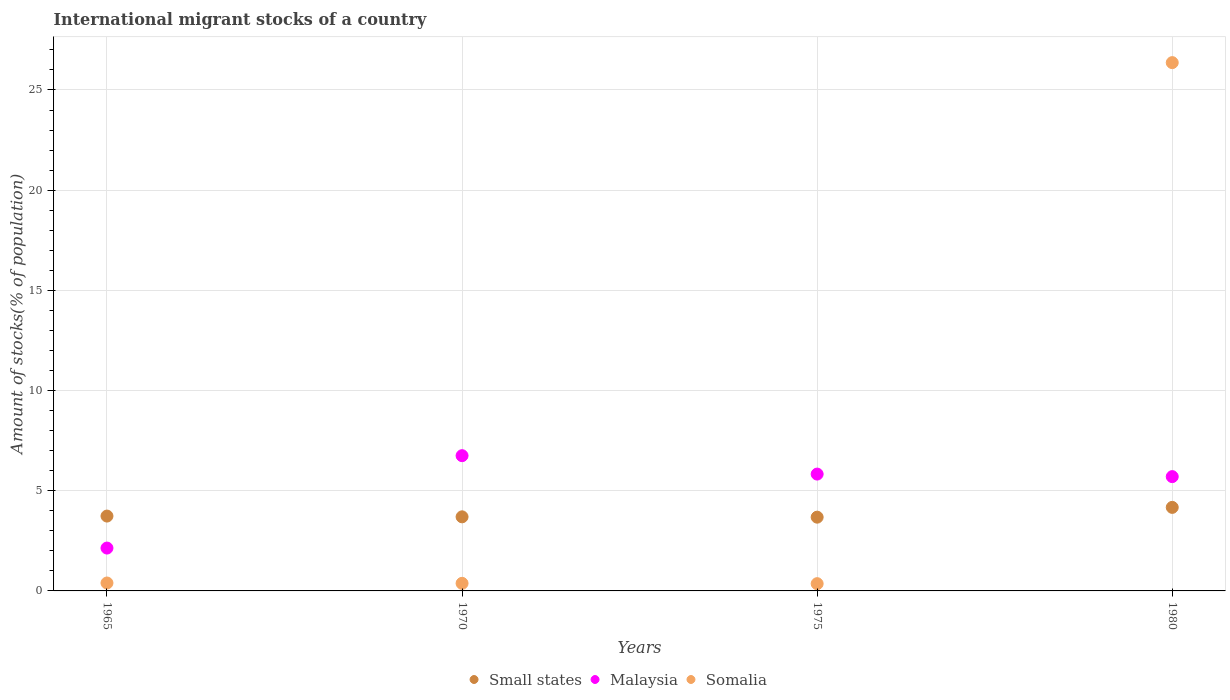Is the number of dotlines equal to the number of legend labels?
Provide a short and direct response. Yes. What is the amount of stocks in in Malaysia in 1965?
Ensure brevity in your answer.  2.14. Across all years, what is the maximum amount of stocks in in Somalia?
Your answer should be compact. 26.37. Across all years, what is the minimum amount of stocks in in Malaysia?
Offer a very short reply. 2.14. In which year was the amount of stocks in in Small states minimum?
Your response must be concise. 1975. What is the total amount of stocks in in Somalia in the graph?
Offer a very short reply. 27.5. What is the difference between the amount of stocks in in Malaysia in 1970 and that in 1975?
Offer a very short reply. 0.92. What is the difference between the amount of stocks in in Small states in 1975 and the amount of stocks in in Malaysia in 1980?
Provide a succinct answer. -2.02. What is the average amount of stocks in in Small states per year?
Provide a short and direct response. 3.82. In the year 1980, what is the difference between the amount of stocks in in Somalia and amount of stocks in in Malaysia?
Your response must be concise. 20.66. What is the ratio of the amount of stocks in in Somalia in 1970 to that in 1975?
Offer a very short reply. 1.05. Is the difference between the amount of stocks in in Somalia in 1975 and 1980 greater than the difference between the amount of stocks in in Malaysia in 1975 and 1980?
Offer a terse response. No. What is the difference between the highest and the second highest amount of stocks in in Small states?
Provide a short and direct response. 0.43. What is the difference between the highest and the lowest amount of stocks in in Small states?
Your answer should be very brief. 0.49. In how many years, is the amount of stocks in in Small states greater than the average amount of stocks in in Small states taken over all years?
Offer a very short reply. 1. Is it the case that in every year, the sum of the amount of stocks in in Somalia and amount of stocks in in Malaysia  is greater than the amount of stocks in in Small states?
Make the answer very short. No. Is the amount of stocks in in Malaysia strictly greater than the amount of stocks in in Somalia over the years?
Your answer should be very brief. No. How many years are there in the graph?
Ensure brevity in your answer.  4. What is the difference between two consecutive major ticks on the Y-axis?
Provide a succinct answer. 5. Are the values on the major ticks of Y-axis written in scientific E-notation?
Provide a short and direct response. No. Does the graph contain grids?
Your answer should be compact. Yes. Where does the legend appear in the graph?
Offer a terse response. Bottom center. What is the title of the graph?
Your response must be concise. International migrant stocks of a country. What is the label or title of the Y-axis?
Give a very brief answer. Amount of stocks(% of population). What is the Amount of stocks(% of population) of Small states in 1965?
Provide a succinct answer. 3.74. What is the Amount of stocks(% of population) in Malaysia in 1965?
Your response must be concise. 2.14. What is the Amount of stocks(% of population) of Somalia in 1965?
Your answer should be very brief. 0.4. What is the Amount of stocks(% of population) of Small states in 1970?
Make the answer very short. 3.7. What is the Amount of stocks(% of population) in Malaysia in 1970?
Offer a very short reply. 6.75. What is the Amount of stocks(% of population) of Somalia in 1970?
Ensure brevity in your answer.  0.38. What is the Amount of stocks(% of population) of Small states in 1975?
Provide a succinct answer. 3.68. What is the Amount of stocks(% of population) of Malaysia in 1975?
Your response must be concise. 5.83. What is the Amount of stocks(% of population) of Somalia in 1975?
Your answer should be compact. 0.36. What is the Amount of stocks(% of population) in Small states in 1980?
Provide a succinct answer. 4.17. What is the Amount of stocks(% of population) in Malaysia in 1980?
Keep it short and to the point. 5.7. What is the Amount of stocks(% of population) in Somalia in 1980?
Your response must be concise. 26.37. Across all years, what is the maximum Amount of stocks(% of population) in Small states?
Offer a very short reply. 4.17. Across all years, what is the maximum Amount of stocks(% of population) of Malaysia?
Ensure brevity in your answer.  6.75. Across all years, what is the maximum Amount of stocks(% of population) of Somalia?
Make the answer very short. 26.37. Across all years, what is the minimum Amount of stocks(% of population) in Small states?
Your answer should be very brief. 3.68. Across all years, what is the minimum Amount of stocks(% of population) of Malaysia?
Your answer should be very brief. 2.14. Across all years, what is the minimum Amount of stocks(% of population) in Somalia?
Provide a short and direct response. 0.36. What is the total Amount of stocks(% of population) in Small states in the graph?
Keep it short and to the point. 15.28. What is the total Amount of stocks(% of population) of Malaysia in the graph?
Make the answer very short. 20.42. What is the total Amount of stocks(% of population) of Somalia in the graph?
Give a very brief answer. 27.5. What is the difference between the Amount of stocks(% of population) in Small states in 1965 and that in 1970?
Provide a succinct answer. 0.04. What is the difference between the Amount of stocks(% of population) in Malaysia in 1965 and that in 1970?
Your response must be concise. -4.61. What is the difference between the Amount of stocks(% of population) of Somalia in 1965 and that in 1970?
Offer a very short reply. 0.02. What is the difference between the Amount of stocks(% of population) in Small states in 1965 and that in 1975?
Your response must be concise. 0.05. What is the difference between the Amount of stocks(% of population) in Malaysia in 1965 and that in 1975?
Offer a very short reply. -3.69. What is the difference between the Amount of stocks(% of population) of Somalia in 1965 and that in 1975?
Your response must be concise. 0.03. What is the difference between the Amount of stocks(% of population) in Small states in 1965 and that in 1980?
Your answer should be very brief. -0.43. What is the difference between the Amount of stocks(% of population) in Malaysia in 1965 and that in 1980?
Your answer should be very brief. -3.57. What is the difference between the Amount of stocks(% of population) in Somalia in 1965 and that in 1980?
Ensure brevity in your answer.  -25.97. What is the difference between the Amount of stocks(% of population) of Small states in 1970 and that in 1975?
Your answer should be very brief. 0.02. What is the difference between the Amount of stocks(% of population) of Malaysia in 1970 and that in 1975?
Give a very brief answer. 0.92. What is the difference between the Amount of stocks(% of population) in Somalia in 1970 and that in 1975?
Make the answer very short. 0.02. What is the difference between the Amount of stocks(% of population) of Small states in 1970 and that in 1980?
Make the answer very short. -0.47. What is the difference between the Amount of stocks(% of population) in Malaysia in 1970 and that in 1980?
Keep it short and to the point. 1.05. What is the difference between the Amount of stocks(% of population) of Somalia in 1970 and that in 1980?
Offer a very short reply. -25.99. What is the difference between the Amount of stocks(% of population) of Small states in 1975 and that in 1980?
Your answer should be very brief. -0.49. What is the difference between the Amount of stocks(% of population) of Malaysia in 1975 and that in 1980?
Ensure brevity in your answer.  0.13. What is the difference between the Amount of stocks(% of population) of Somalia in 1975 and that in 1980?
Your answer should be compact. -26. What is the difference between the Amount of stocks(% of population) of Small states in 1965 and the Amount of stocks(% of population) of Malaysia in 1970?
Your answer should be very brief. -3.01. What is the difference between the Amount of stocks(% of population) of Small states in 1965 and the Amount of stocks(% of population) of Somalia in 1970?
Your answer should be compact. 3.36. What is the difference between the Amount of stocks(% of population) in Malaysia in 1965 and the Amount of stocks(% of population) in Somalia in 1970?
Your answer should be compact. 1.76. What is the difference between the Amount of stocks(% of population) in Small states in 1965 and the Amount of stocks(% of population) in Malaysia in 1975?
Ensure brevity in your answer.  -2.1. What is the difference between the Amount of stocks(% of population) of Small states in 1965 and the Amount of stocks(% of population) of Somalia in 1975?
Give a very brief answer. 3.37. What is the difference between the Amount of stocks(% of population) in Malaysia in 1965 and the Amount of stocks(% of population) in Somalia in 1975?
Ensure brevity in your answer.  1.78. What is the difference between the Amount of stocks(% of population) in Small states in 1965 and the Amount of stocks(% of population) in Malaysia in 1980?
Provide a succinct answer. -1.97. What is the difference between the Amount of stocks(% of population) of Small states in 1965 and the Amount of stocks(% of population) of Somalia in 1980?
Provide a short and direct response. -22.63. What is the difference between the Amount of stocks(% of population) in Malaysia in 1965 and the Amount of stocks(% of population) in Somalia in 1980?
Make the answer very short. -24.23. What is the difference between the Amount of stocks(% of population) in Small states in 1970 and the Amount of stocks(% of population) in Malaysia in 1975?
Provide a short and direct response. -2.13. What is the difference between the Amount of stocks(% of population) of Small states in 1970 and the Amount of stocks(% of population) of Somalia in 1975?
Provide a short and direct response. 3.34. What is the difference between the Amount of stocks(% of population) in Malaysia in 1970 and the Amount of stocks(% of population) in Somalia in 1975?
Make the answer very short. 6.39. What is the difference between the Amount of stocks(% of population) of Small states in 1970 and the Amount of stocks(% of population) of Malaysia in 1980?
Provide a short and direct response. -2.01. What is the difference between the Amount of stocks(% of population) of Small states in 1970 and the Amount of stocks(% of population) of Somalia in 1980?
Ensure brevity in your answer.  -22.67. What is the difference between the Amount of stocks(% of population) of Malaysia in 1970 and the Amount of stocks(% of population) of Somalia in 1980?
Provide a short and direct response. -19.62. What is the difference between the Amount of stocks(% of population) in Small states in 1975 and the Amount of stocks(% of population) in Malaysia in 1980?
Keep it short and to the point. -2.02. What is the difference between the Amount of stocks(% of population) of Small states in 1975 and the Amount of stocks(% of population) of Somalia in 1980?
Ensure brevity in your answer.  -22.69. What is the difference between the Amount of stocks(% of population) of Malaysia in 1975 and the Amount of stocks(% of population) of Somalia in 1980?
Your answer should be compact. -20.54. What is the average Amount of stocks(% of population) of Small states per year?
Give a very brief answer. 3.82. What is the average Amount of stocks(% of population) in Malaysia per year?
Provide a short and direct response. 5.11. What is the average Amount of stocks(% of population) in Somalia per year?
Your answer should be compact. 6.88. In the year 1965, what is the difference between the Amount of stocks(% of population) of Small states and Amount of stocks(% of population) of Malaysia?
Ensure brevity in your answer.  1.6. In the year 1965, what is the difference between the Amount of stocks(% of population) of Small states and Amount of stocks(% of population) of Somalia?
Provide a short and direct response. 3.34. In the year 1965, what is the difference between the Amount of stocks(% of population) of Malaysia and Amount of stocks(% of population) of Somalia?
Give a very brief answer. 1.74. In the year 1970, what is the difference between the Amount of stocks(% of population) in Small states and Amount of stocks(% of population) in Malaysia?
Provide a short and direct response. -3.05. In the year 1970, what is the difference between the Amount of stocks(% of population) in Small states and Amount of stocks(% of population) in Somalia?
Provide a succinct answer. 3.32. In the year 1970, what is the difference between the Amount of stocks(% of population) of Malaysia and Amount of stocks(% of population) of Somalia?
Keep it short and to the point. 6.37. In the year 1975, what is the difference between the Amount of stocks(% of population) in Small states and Amount of stocks(% of population) in Malaysia?
Make the answer very short. -2.15. In the year 1975, what is the difference between the Amount of stocks(% of population) of Small states and Amount of stocks(% of population) of Somalia?
Make the answer very short. 3.32. In the year 1975, what is the difference between the Amount of stocks(% of population) of Malaysia and Amount of stocks(% of population) of Somalia?
Offer a terse response. 5.47. In the year 1980, what is the difference between the Amount of stocks(% of population) of Small states and Amount of stocks(% of population) of Malaysia?
Give a very brief answer. -1.54. In the year 1980, what is the difference between the Amount of stocks(% of population) in Small states and Amount of stocks(% of population) in Somalia?
Your response must be concise. -22.2. In the year 1980, what is the difference between the Amount of stocks(% of population) in Malaysia and Amount of stocks(% of population) in Somalia?
Give a very brief answer. -20.66. What is the ratio of the Amount of stocks(% of population) of Small states in 1965 to that in 1970?
Provide a succinct answer. 1.01. What is the ratio of the Amount of stocks(% of population) in Malaysia in 1965 to that in 1970?
Your response must be concise. 0.32. What is the ratio of the Amount of stocks(% of population) in Somalia in 1965 to that in 1970?
Provide a short and direct response. 1.04. What is the ratio of the Amount of stocks(% of population) in Small states in 1965 to that in 1975?
Offer a very short reply. 1.01. What is the ratio of the Amount of stocks(% of population) of Malaysia in 1965 to that in 1975?
Keep it short and to the point. 0.37. What is the ratio of the Amount of stocks(% of population) in Somalia in 1965 to that in 1975?
Make the answer very short. 1.09. What is the ratio of the Amount of stocks(% of population) in Small states in 1965 to that in 1980?
Provide a short and direct response. 0.9. What is the ratio of the Amount of stocks(% of population) in Malaysia in 1965 to that in 1980?
Provide a short and direct response. 0.37. What is the ratio of the Amount of stocks(% of population) of Somalia in 1965 to that in 1980?
Provide a short and direct response. 0.01. What is the ratio of the Amount of stocks(% of population) in Small states in 1970 to that in 1975?
Your answer should be very brief. 1. What is the ratio of the Amount of stocks(% of population) of Malaysia in 1970 to that in 1975?
Ensure brevity in your answer.  1.16. What is the ratio of the Amount of stocks(% of population) in Somalia in 1970 to that in 1975?
Ensure brevity in your answer.  1.05. What is the ratio of the Amount of stocks(% of population) in Small states in 1970 to that in 1980?
Provide a short and direct response. 0.89. What is the ratio of the Amount of stocks(% of population) of Malaysia in 1970 to that in 1980?
Give a very brief answer. 1.18. What is the ratio of the Amount of stocks(% of population) in Somalia in 1970 to that in 1980?
Keep it short and to the point. 0.01. What is the ratio of the Amount of stocks(% of population) of Small states in 1975 to that in 1980?
Keep it short and to the point. 0.88. What is the ratio of the Amount of stocks(% of population) of Malaysia in 1975 to that in 1980?
Your answer should be compact. 1.02. What is the ratio of the Amount of stocks(% of population) in Somalia in 1975 to that in 1980?
Offer a terse response. 0.01. What is the difference between the highest and the second highest Amount of stocks(% of population) of Small states?
Ensure brevity in your answer.  0.43. What is the difference between the highest and the second highest Amount of stocks(% of population) of Malaysia?
Keep it short and to the point. 0.92. What is the difference between the highest and the second highest Amount of stocks(% of population) of Somalia?
Give a very brief answer. 25.97. What is the difference between the highest and the lowest Amount of stocks(% of population) in Small states?
Your answer should be compact. 0.49. What is the difference between the highest and the lowest Amount of stocks(% of population) of Malaysia?
Offer a very short reply. 4.61. What is the difference between the highest and the lowest Amount of stocks(% of population) in Somalia?
Your answer should be very brief. 26. 